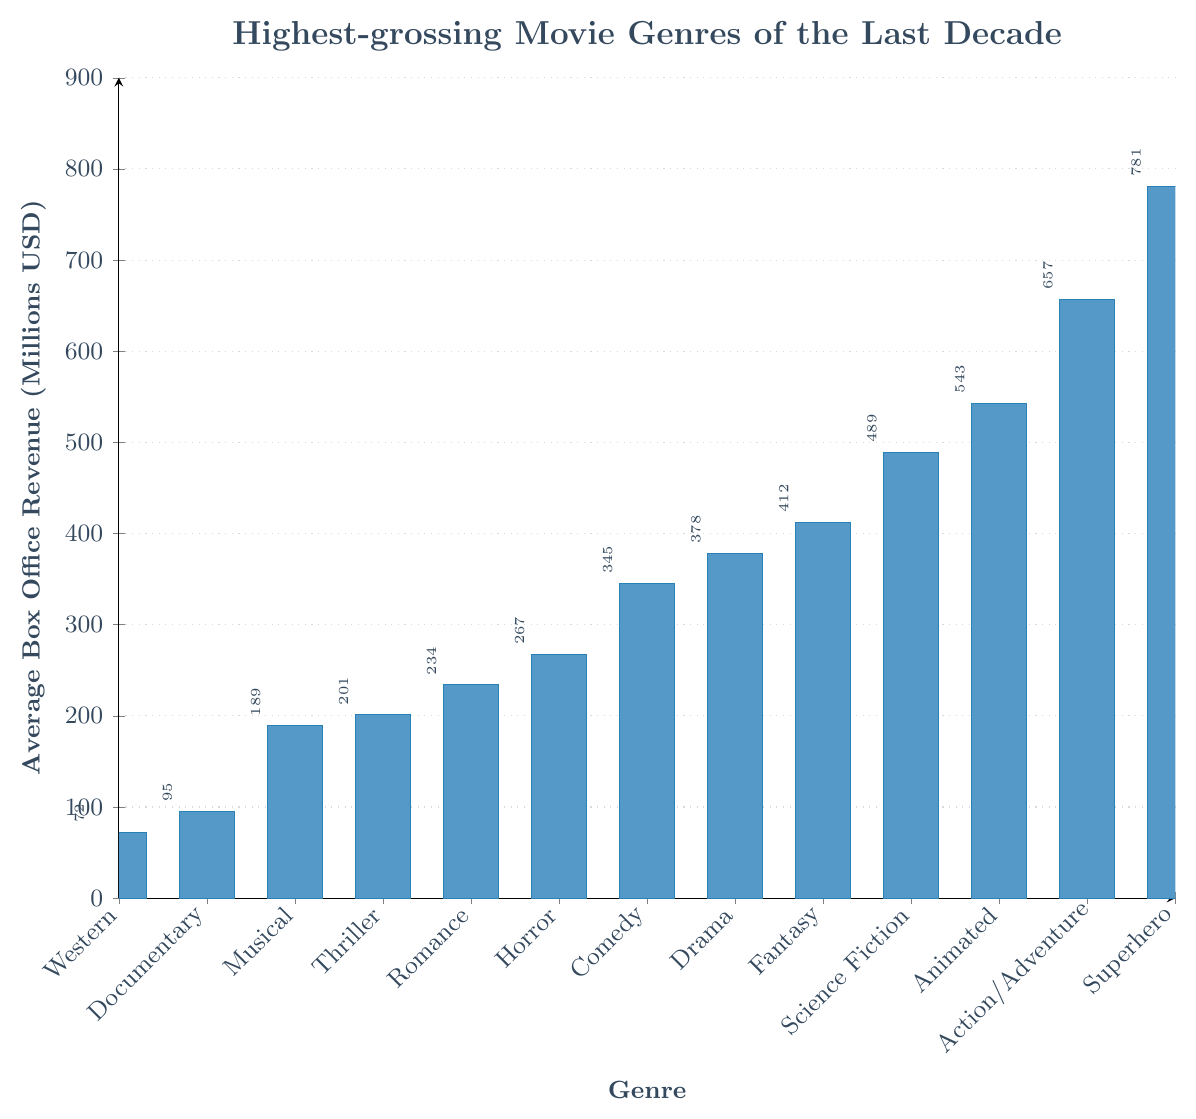What's the highest-grossing movie genre of the last decade? The highest-grossing movie genre can be identified by looking for the tallest bar in the bar chart. The bar representing 'Superhero' is the tallest, indicating it has the highest average box office revenue.
Answer: Superhero Which genre has the lowest average box office revenue? The genre with the lowest average box office revenue can be identified by locating the shortest bar in the bar chart. The shortest bar is representing 'Western'.
Answer: Western How much more does the Superhero genre make on average compared to the Horror genre? First, identify the average box office revenue for Superhero and Horror genres, which are 781 million USD and 267 million USD respectively. Then, subtract the revenue of the Horror genre from the Superhero genre: 781 - 267 = 514 million USD.
Answer: 514 million USD Rank the genres Drama, Comedy, and Horror from highest to lowest average box office revenue. To rank the genres, compare their respective revenue: Drama (378 million USD), Comedy (345 million USD), and Horror (267 million USD). Arranging from highest to lowest, we get Drama, Comedy, Horror.
Answer: Drama, Comedy, Horror What's the average revenue of Documentary, Musical, and Western genres combined? First, find the average revenues for Documentary (95 million USD), Musical (189 million USD), and Western (72 million USD). Next, sum these values: 95 + 189 + 72 = 356 million USD. Finally, divide by the number of genres: 356 / 3 ≈ 119 million USD.
Answer: 119 million USD Which genre makes slightly less on average than Science Fiction but more than Comedy? Compare the average revenues to find the genre that falls between Science Fiction (489 million USD) and Comedy (345 million USD). The bar for Fantasy averages 412 million USD, which fits the criterion.
Answer: Fantasy How much do Action/Adventure and Animated genres make combined on average? First, find the average revenues for Action/Adventure (657 million USD) and Animated (543 million USD). Then, sum these values: 657 + 543 = 1200 million USD.
Answer: 1200 million USD Compare the average box office revenues of the top 3 highest-grossing genres. The top 3 highest-grossing genres are Superhero (781 million USD), Action/Adventure (657 million USD), and Animated (543 million USD). Each genre can be compared to see that Superhero is greater than Action/Adventure, and Action/Adventure is greater than Animated.
Answer: Superhero > Action/Adventure > Animated Which genre's average box office revenue is closest to 500 million USD? Review the revenues to find the closest value to 500 million USD. Science Fiction, with an average of 489 million USD, is the closest.
Answer: Science Fiction 